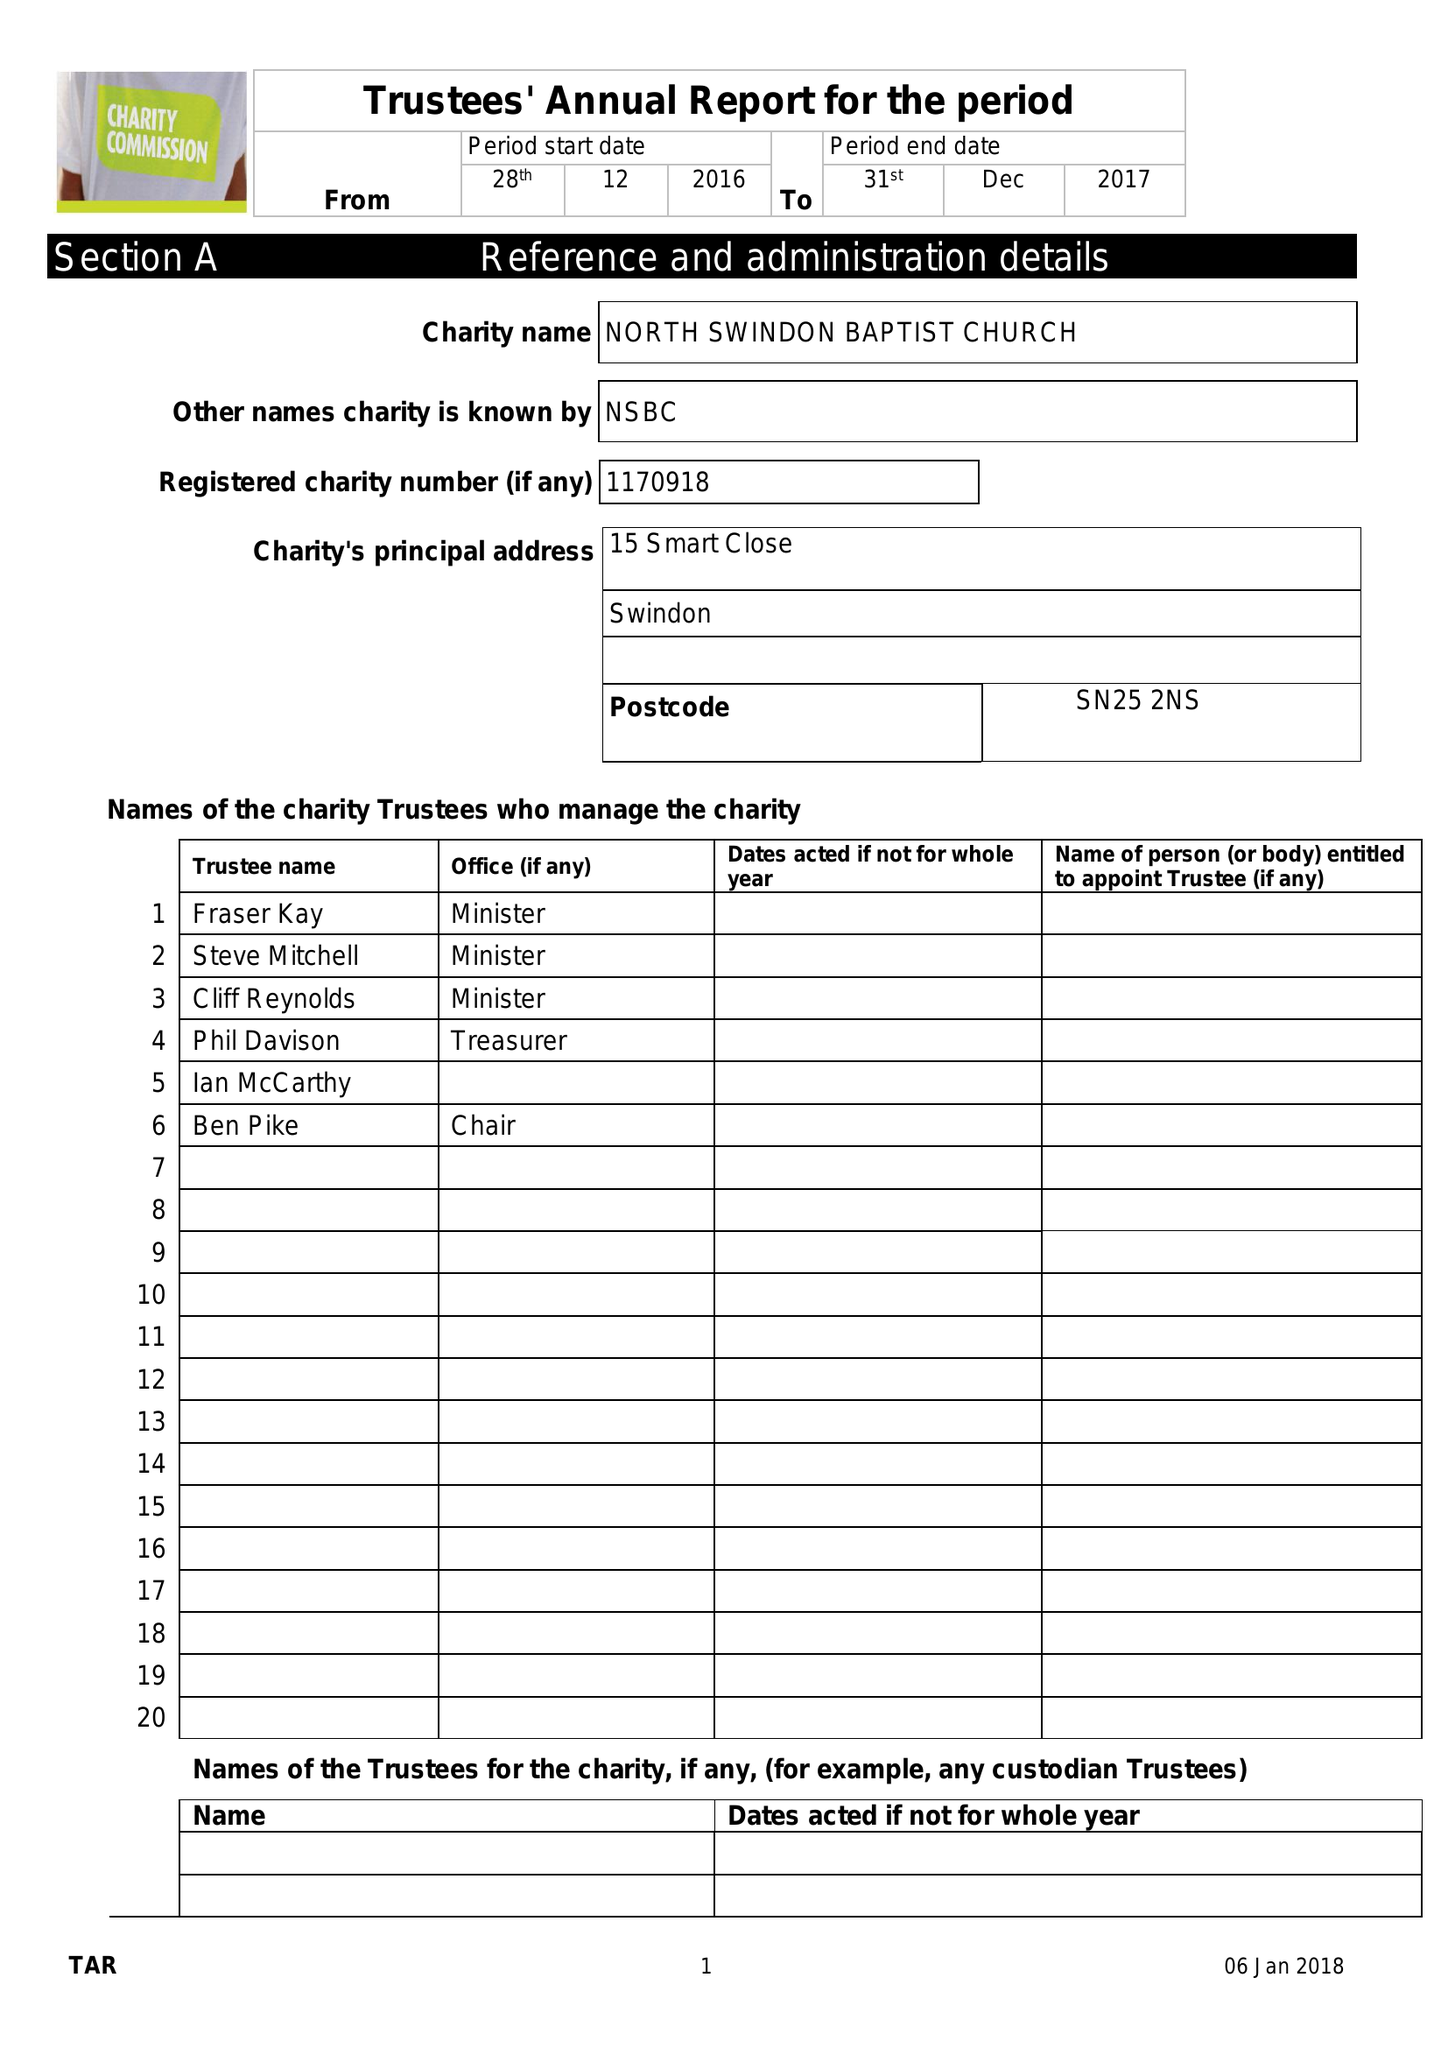What is the value for the address__street_line?
Answer the question using a single word or phrase. 15 SMART CLOSE 